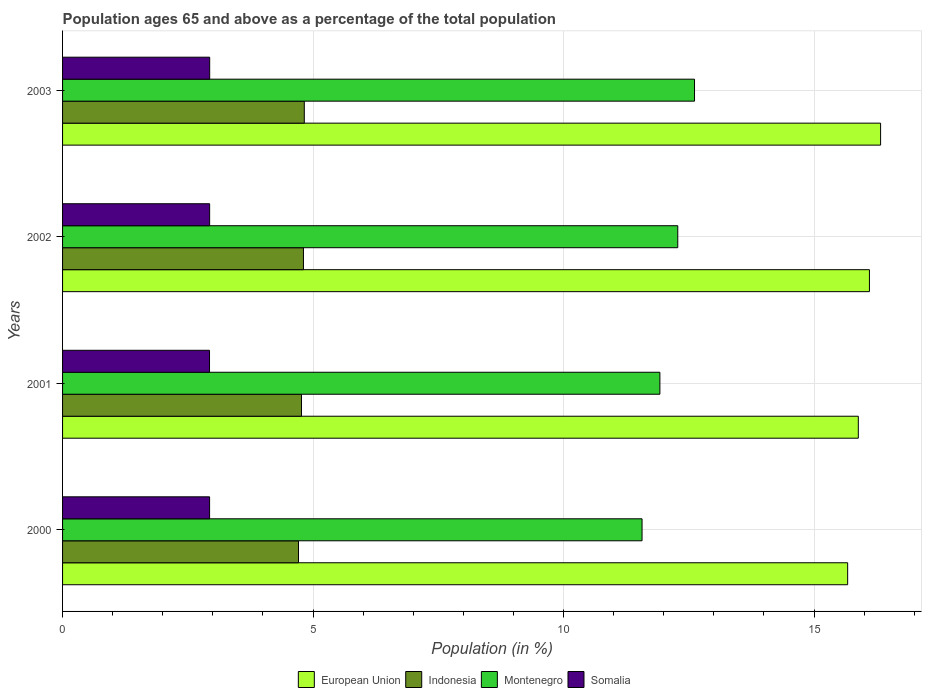How many different coloured bars are there?
Provide a short and direct response. 4. How many groups of bars are there?
Offer a very short reply. 4. How many bars are there on the 1st tick from the top?
Your answer should be compact. 4. How many bars are there on the 3rd tick from the bottom?
Your response must be concise. 4. What is the label of the 4th group of bars from the top?
Make the answer very short. 2000. In how many cases, is the number of bars for a given year not equal to the number of legend labels?
Offer a terse response. 0. What is the percentage of the population ages 65 and above in European Union in 2002?
Keep it short and to the point. 16.11. Across all years, what is the maximum percentage of the population ages 65 and above in Indonesia?
Provide a succinct answer. 4.83. Across all years, what is the minimum percentage of the population ages 65 and above in European Union?
Keep it short and to the point. 15.67. In which year was the percentage of the population ages 65 and above in Montenegro maximum?
Offer a terse response. 2003. What is the total percentage of the population ages 65 and above in European Union in the graph?
Your response must be concise. 63.99. What is the difference between the percentage of the population ages 65 and above in Montenegro in 2000 and that in 2003?
Ensure brevity in your answer.  -1.05. What is the difference between the percentage of the population ages 65 and above in Montenegro in 2001 and the percentage of the population ages 65 and above in Indonesia in 2002?
Provide a short and direct response. 7.11. What is the average percentage of the population ages 65 and above in Indonesia per year?
Offer a terse response. 4.78. In the year 2002, what is the difference between the percentage of the population ages 65 and above in Somalia and percentage of the population ages 65 and above in Montenegro?
Keep it short and to the point. -9.34. What is the ratio of the percentage of the population ages 65 and above in Somalia in 2000 to that in 2001?
Your answer should be very brief. 1. Is the percentage of the population ages 65 and above in Indonesia in 2001 less than that in 2003?
Your response must be concise. Yes. Is the difference between the percentage of the population ages 65 and above in Somalia in 2001 and 2003 greater than the difference between the percentage of the population ages 65 and above in Montenegro in 2001 and 2003?
Make the answer very short. Yes. What is the difference between the highest and the second highest percentage of the population ages 65 and above in Somalia?
Offer a very short reply. 0. What is the difference between the highest and the lowest percentage of the population ages 65 and above in Indonesia?
Offer a terse response. 0.12. In how many years, is the percentage of the population ages 65 and above in Somalia greater than the average percentage of the population ages 65 and above in Somalia taken over all years?
Offer a terse response. 2. Is the sum of the percentage of the population ages 65 and above in Montenegro in 2000 and 2003 greater than the maximum percentage of the population ages 65 and above in Somalia across all years?
Your answer should be very brief. Yes. Is it the case that in every year, the sum of the percentage of the population ages 65 and above in European Union and percentage of the population ages 65 and above in Montenegro is greater than the sum of percentage of the population ages 65 and above in Indonesia and percentage of the population ages 65 and above in Somalia?
Provide a succinct answer. Yes. What does the 2nd bar from the top in 2000 represents?
Your answer should be very brief. Montenegro. What does the 4th bar from the bottom in 2001 represents?
Make the answer very short. Somalia. How many bars are there?
Offer a terse response. 16. Are the values on the major ticks of X-axis written in scientific E-notation?
Ensure brevity in your answer.  No. Does the graph contain any zero values?
Your answer should be compact. No. Where does the legend appear in the graph?
Offer a very short reply. Bottom center. How many legend labels are there?
Make the answer very short. 4. What is the title of the graph?
Offer a very short reply. Population ages 65 and above as a percentage of the total population. What is the label or title of the Y-axis?
Make the answer very short. Years. What is the Population (in %) of European Union in 2000?
Offer a terse response. 15.67. What is the Population (in %) of Indonesia in 2000?
Your answer should be compact. 4.71. What is the Population (in %) of Montenegro in 2000?
Your answer should be compact. 11.57. What is the Population (in %) in Somalia in 2000?
Your answer should be very brief. 2.93. What is the Population (in %) in European Union in 2001?
Your answer should be very brief. 15.88. What is the Population (in %) in Indonesia in 2001?
Offer a very short reply. 4.77. What is the Population (in %) in Montenegro in 2001?
Your response must be concise. 11.92. What is the Population (in %) in Somalia in 2001?
Give a very brief answer. 2.93. What is the Population (in %) in European Union in 2002?
Offer a terse response. 16.11. What is the Population (in %) in Indonesia in 2002?
Make the answer very short. 4.81. What is the Population (in %) of Montenegro in 2002?
Make the answer very short. 12.28. What is the Population (in %) in Somalia in 2002?
Your response must be concise. 2.94. What is the Population (in %) of European Union in 2003?
Make the answer very short. 16.33. What is the Population (in %) in Indonesia in 2003?
Your answer should be compact. 4.83. What is the Population (in %) of Montenegro in 2003?
Your answer should be very brief. 12.61. What is the Population (in %) of Somalia in 2003?
Offer a very short reply. 2.94. Across all years, what is the maximum Population (in %) in European Union?
Offer a terse response. 16.33. Across all years, what is the maximum Population (in %) in Indonesia?
Keep it short and to the point. 4.83. Across all years, what is the maximum Population (in %) of Montenegro?
Keep it short and to the point. 12.61. Across all years, what is the maximum Population (in %) of Somalia?
Provide a short and direct response. 2.94. Across all years, what is the minimum Population (in %) of European Union?
Make the answer very short. 15.67. Across all years, what is the minimum Population (in %) in Indonesia?
Make the answer very short. 4.71. Across all years, what is the minimum Population (in %) of Montenegro?
Your response must be concise. 11.57. Across all years, what is the minimum Population (in %) in Somalia?
Your response must be concise. 2.93. What is the total Population (in %) of European Union in the graph?
Give a very brief answer. 63.99. What is the total Population (in %) in Indonesia in the graph?
Your answer should be compact. 19.11. What is the total Population (in %) in Montenegro in the graph?
Ensure brevity in your answer.  48.39. What is the total Population (in %) of Somalia in the graph?
Offer a terse response. 11.74. What is the difference between the Population (in %) in European Union in 2000 and that in 2001?
Your answer should be compact. -0.21. What is the difference between the Population (in %) in Indonesia in 2000 and that in 2001?
Provide a succinct answer. -0.06. What is the difference between the Population (in %) of Montenegro in 2000 and that in 2001?
Your response must be concise. -0.36. What is the difference between the Population (in %) of Somalia in 2000 and that in 2001?
Provide a succinct answer. 0. What is the difference between the Population (in %) in European Union in 2000 and that in 2002?
Provide a succinct answer. -0.43. What is the difference between the Population (in %) of Indonesia in 2000 and that in 2002?
Provide a short and direct response. -0.1. What is the difference between the Population (in %) in Montenegro in 2000 and that in 2002?
Provide a succinct answer. -0.71. What is the difference between the Population (in %) in Somalia in 2000 and that in 2002?
Make the answer very short. -0. What is the difference between the Population (in %) in European Union in 2000 and that in 2003?
Give a very brief answer. -0.66. What is the difference between the Population (in %) of Indonesia in 2000 and that in 2003?
Make the answer very short. -0.12. What is the difference between the Population (in %) in Montenegro in 2000 and that in 2003?
Offer a very short reply. -1.05. What is the difference between the Population (in %) in Somalia in 2000 and that in 2003?
Make the answer very short. -0. What is the difference between the Population (in %) of European Union in 2001 and that in 2002?
Your response must be concise. -0.22. What is the difference between the Population (in %) in Indonesia in 2001 and that in 2002?
Make the answer very short. -0.04. What is the difference between the Population (in %) in Montenegro in 2001 and that in 2002?
Offer a very short reply. -0.36. What is the difference between the Population (in %) of Somalia in 2001 and that in 2002?
Make the answer very short. -0. What is the difference between the Population (in %) of European Union in 2001 and that in 2003?
Keep it short and to the point. -0.44. What is the difference between the Population (in %) in Indonesia in 2001 and that in 2003?
Make the answer very short. -0.06. What is the difference between the Population (in %) of Montenegro in 2001 and that in 2003?
Provide a succinct answer. -0.69. What is the difference between the Population (in %) of Somalia in 2001 and that in 2003?
Provide a succinct answer. -0. What is the difference between the Population (in %) in European Union in 2002 and that in 2003?
Provide a succinct answer. -0.22. What is the difference between the Population (in %) of Indonesia in 2002 and that in 2003?
Provide a succinct answer. -0.02. What is the difference between the Population (in %) in Montenegro in 2002 and that in 2003?
Your answer should be compact. -0.33. What is the difference between the Population (in %) of Somalia in 2002 and that in 2003?
Your response must be concise. -0. What is the difference between the Population (in %) in European Union in 2000 and the Population (in %) in Indonesia in 2001?
Offer a terse response. 10.9. What is the difference between the Population (in %) of European Union in 2000 and the Population (in %) of Montenegro in 2001?
Your answer should be very brief. 3.75. What is the difference between the Population (in %) in European Union in 2000 and the Population (in %) in Somalia in 2001?
Ensure brevity in your answer.  12.74. What is the difference between the Population (in %) of Indonesia in 2000 and the Population (in %) of Montenegro in 2001?
Offer a very short reply. -7.21. What is the difference between the Population (in %) in Indonesia in 2000 and the Population (in %) in Somalia in 2001?
Provide a succinct answer. 1.78. What is the difference between the Population (in %) of Montenegro in 2000 and the Population (in %) of Somalia in 2001?
Give a very brief answer. 8.63. What is the difference between the Population (in %) in European Union in 2000 and the Population (in %) in Indonesia in 2002?
Your answer should be compact. 10.86. What is the difference between the Population (in %) of European Union in 2000 and the Population (in %) of Montenegro in 2002?
Offer a very short reply. 3.39. What is the difference between the Population (in %) of European Union in 2000 and the Population (in %) of Somalia in 2002?
Provide a succinct answer. 12.74. What is the difference between the Population (in %) in Indonesia in 2000 and the Population (in %) in Montenegro in 2002?
Offer a terse response. -7.57. What is the difference between the Population (in %) in Indonesia in 2000 and the Population (in %) in Somalia in 2002?
Ensure brevity in your answer.  1.77. What is the difference between the Population (in %) of Montenegro in 2000 and the Population (in %) of Somalia in 2002?
Ensure brevity in your answer.  8.63. What is the difference between the Population (in %) of European Union in 2000 and the Population (in %) of Indonesia in 2003?
Offer a terse response. 10.85. What is the difference between the Population (in %) in European Union in 2000 and the Population (in %) in Montenegro in 2003?
Provide a succinct answer. 3.06. What is the difference between the Population (in %) in European Union in 2000 and the Population (in %) in Somalia in 2003?
Your answer should be very brief. 12.73. What is the difference between the Population (in %) in Indonesia in 2000 and the Population (in %) in Montenegro in 2003?
Provide a succinct answer. -7.91. What is the difference between the Population (in %) of Indonesia in 2000 and the Population (in %) of Somalia in 2003?
Your response must be concise. 1.77. What is the difference between the Population (in %) of Montenegro in 2000 and the Population (in %) of Somalia in 2003?
Provide a short and direct response. 8.63. What is the difference between the Population (in %) in European Union in 2001 and the Population (in %) in Indonesia in 2002?
Provide a succinct answer. 11.08. What is the difference between the Population (in %) of European Union in 2001 and the Population (in %) of Montenegro in 2002?
Your response must be concise. 3.6. What is the difference between the Population (in %) of European Union in 2001 and the Population (in %) of Somalia in 2002?
Your response must be concise. 12.95. What is the difference between the Population (in %) of Indonesia in 2001 and the Population (in %) of Montenegro in 2002?
Ensure brevity in your answer.  -7.51. What is the difference between the Population (in %) of Indonesia in 2001 and the Population (in %) of Somalia in 2002?
Offer a very short reply. 1.83. What is the difference between the Population (in %) in Montenegro in 2001 and the Population (in %) in Somalia in 2002?
Provide a short and direct response. 8.99. What is the difference between the Population (in %) in European Union in 2001 and the Population (in %) in Indonesia in 2003?
Offer a terse response. 11.06. What is the difference between the Population (in %) of European Union in 2001 and the Population (in %) of Montenegro in 2003?
Your answer should be very brief. 3.27. What is the difference between the Population (in %) of European Union in 2001 and the Population (in %) of Somalia in 2003?
Provide a short and direct response. 12.95. What is the difference between the Population (in %) of Indonesia in 2001 and the Population (in %) of Montenegro in 2003?
Give a very brief answer. -7.85. What is the difference between the Population (in %) of Indonesia in 2001 and the Population (in %) of Somalia in 2003?
Your answer should be very brief. 1.83. What is the difference between the Population (in %) in Montenegro in 2001 and the Population (in %) in Somalia in 2003?
Your response must be concise. 8.99. What is the difference between the Population (in %) in European Union in 2002 and the Population (in %) in Indonesia in 2003?
Provide a succinct answer. 11.28. What is the difference between the Population (in %) of European Union in 2002 and the Population (in %) of Montenegro in 2003?
Make the answer very short. 3.49. What is the difference between the Population (in %) of European Union in 2002 and the Population (in %) of Somalia in 2003?
Your response must be concise. 13.17. What is the difference between the Population (in %) of Indonesia in 2002 and the Population (in %) of Montenegro in 2003?
Offer a terse response. -7.81. What is the difference between the Population (in %) in Indonesia in 2002 and the Population (in %) in Somalia in 2003?
Your response must be concise. 1.87. What is the difference between the Population (in %) of Montenegro in 2002 and the Population (in %) of Somalia in 2003?
Provide a short and direct response. 9.34. What is the average Population (in %) in European Union per year?
Provide a short and direct response. 16. What is the average Population (in %) of Indonesia per year?
Provide a succinct answer. 4.78. What is the average Population (in %) of Montenegro per year?
Keep it short and to the point. 12.1. What is the average Population (in %) in Somalia per year?
Keep it short and to the point. 2.94. In the year 2000, what is the difference between the Population (in %) of European Union and Population (in %) of Indonesia?
Offer a terse response. 10.96. In the year 2000, what is the difference between the Population (in %) in European Union and Population (in %) in Montenegro?
Your answer should be compact. 4.1. In the year 2000, what is the difference between the Population (in %) of European Union and Population (in %) of Somalia?
Give a very brief answer. 12.74. In the year 2000, what is the difference between the Population (in %) in Indonesia and Population (in %) in Montenegro?
Offer a very short reply. -6.86. In the year 2000, what is the difference between the Population (in %) in Indonesia and Population (in %) in Somalia?
Ensure brevity in your answer.  1.77. In the year 2000, what is the difference between the Population (in %) of Montenegro and Population (in %) of Somalia?
Provide a succinct answer. 8.63. In the year 2001, what is the difference between the Population (in %) in European Union and Population (in %) in Indonesia?
Give a very brief answer. 11.11. In the year 2001, what is the difference between the Population (in %) in European Union and Population (in %) in Montenegro?
Provide a short and direct response. 3.96. In the year 2001, what is the difference between the Population (in %) in European Union and Population (in %) in Somalia?
Offer a very short reply. 12.95. In the year 2001, what is the difference between the Population (in %) in Indonesia and Population (in %) in Montenegro?
Your answer should be very brief. -7.15. In the year 2001, what is the difference between the Population (in %) in Indonesia and Population (in %) in Somalia?
Offer a very short reply. 1.84. In the year 2001, what is the difference between the Population (in %) of Montenegro and Population (in %) of Somalia?
Ensure brevity in your answer.  8.99. In the year 2002, what is the difference between the Population (in %) in European Union and Population (in %) in Indonesia?
Your answer should be very brief. 11.3. In the year 2002, what is the difference between the Population (in %) of European Union and Population (in %) of Montenegro?
Offer a terse response. 3.83. In the year 2002, what is the difference between the Population (in %) in European Union and Population (in %) in Somalia?
Keep it short and to the point. 13.17. In the year 2002, what is the difference between the Population (in %) of Indonesia and Population (in %) of Montenegro?
Your answer should be compact. -7.47. In the year 2002, what is the difference between the Population (in %) in Indonesia and Population (in %) in Somalia?
Provide a short and direct response. 1.87. In the year 2002, what is the difference between the Population (in %) of Montenegro and Population (in %) of Somalia?
Your response must be concise. 9.34. In the year 2003, what is the difference between the Population (in %) of European Union and Population (in %) of Indonesia?
Offer a terse response. 11.5. In the year 2003, what is the difference between the Population (in %) in European Union and Population (in %) in Montenegro?
Offer a terse response. 3.71. In the year 2003, what is the difference between the Population (in %) in European Union and Population (in %) in Somalia?
Give a very brief answer. 13.39. In the year 2003, what is the difference between the Population (in %) of Indonesia and Population (in %) of Montenegro?
Provide a short and direct response. -7.79. In the year 2003, what is the difference between the Population (in %) in Indonesia and Population (in %) in Somalia?
Offer a terse response. 1.89. In the year 2003, what is the difference between the Population (in %) in Montenegro and Population (in %) in Somalia?
Give a very brief answer. 9.68. What is the ratio of the Population (in %) of European Union in 2000 to that in 2001?
Your answer should be very brief. 0.99. What is the ratio of the Population (in %) in Indonesia in 2000 to that in 2001?
Give a very brief answer. 0.99. What is the ratio of the Population (in %) of Montenegro in 2000 to that in 2001?
Offer a terse response. 0.97. What is the ratio of the Population (in %) in Somalia in 2000 to that in 2001?
Your response must be concise. 1. What is the ratio of the Population (in %) of Indonesia in 2000 to that in 2002?
Your answer should be very brief. 0.98. What is the ratio of the Population (in %) of Montenegro in 2000 to that in 2002?
Your answer should be compact. 0.94. What is the ratio of the Population (in %) of Somalia in 2000 to that in 2002?
Offer a terse response. 1. What is the ratio of the Population (in %) in European Union in 2000 to that in 2003?
Offer a terse response. 0.96. What is the ratio of the Population (in %) of Montenegro in 2000 to that in 2003?
Offer a very short reply. 0.92. What is the ratio of the Population (in %) in Somalia in 2000 to that in 2003?
Offer a terse response. 1. What is the ratio of the Population (in %) of European Union in 2001 to that in 2002?
Keep it short and to the point. 0.99. What is the ratio of the Population (in %) of Indonesia in 2001 to that in 2002?
Offer a very short reply. 0.99. What is the ratio of the Population (in %) of Montenegro in 2001 to that in 2002?
Offer a very short reply. 0.97. What is the ratio of the Population (in %) of European Union in 2001 to that in 2003?
Offer a terse response. 0.97. What is the ratio of the Population (in %) of Indonesia in 2001 to that in 2003?
Keep it short and to the point. 0.99. What is the ratio of the Population (in %) of Montenegro in 2001 to that in 2003?
Provide a short and direct response. 0.95. What is the ratio of the Population (in %) of Somalia in 2001 to that in 2003?
Make the answer very short. 1. What is the ratio of the Population (in %) of European Union in 2002 to that in 2003?
Your response must be concise. 0.99. What is the ratio of the Population (in %) of Montenegro in 2002 to that in 2003?
Your answer should be very brief. 0.97. What is the ratio of the Population (in %) of Somalia in 2002 to that in 2003?
Ensure brevity in your answer.  1. What is the difference between the highest and the second highest Population (in %) of European Union?
Provide a succinct answer. 0.22. What is the difference between the highest and the second highest Population (in %) of Indonesia?
Give a very brief answer. 0.02. What is the difference between the highest and the second highest Population (in %) of Montenegro?
Ensure brevity in your answer.  0.33. What is the difference between the highest and the second highest Population (in %) of Somalia?
Make the answer very short. 0. What is the difference between the highest and the lowest Population (in %) in European Union?
Your answer should be very brief. 0.66. What is the difference between the highest and the lowest Population (in %) in Indonesia?
Give a very brief answer. 0.12. What is the difference between the highest and the lowest Population (in %) in Montenegro?
Your response must be concise. 1.05. What is the difference between the highest and the lowest Population (in %) of Somalia?
Your answer should be compact. 0. 